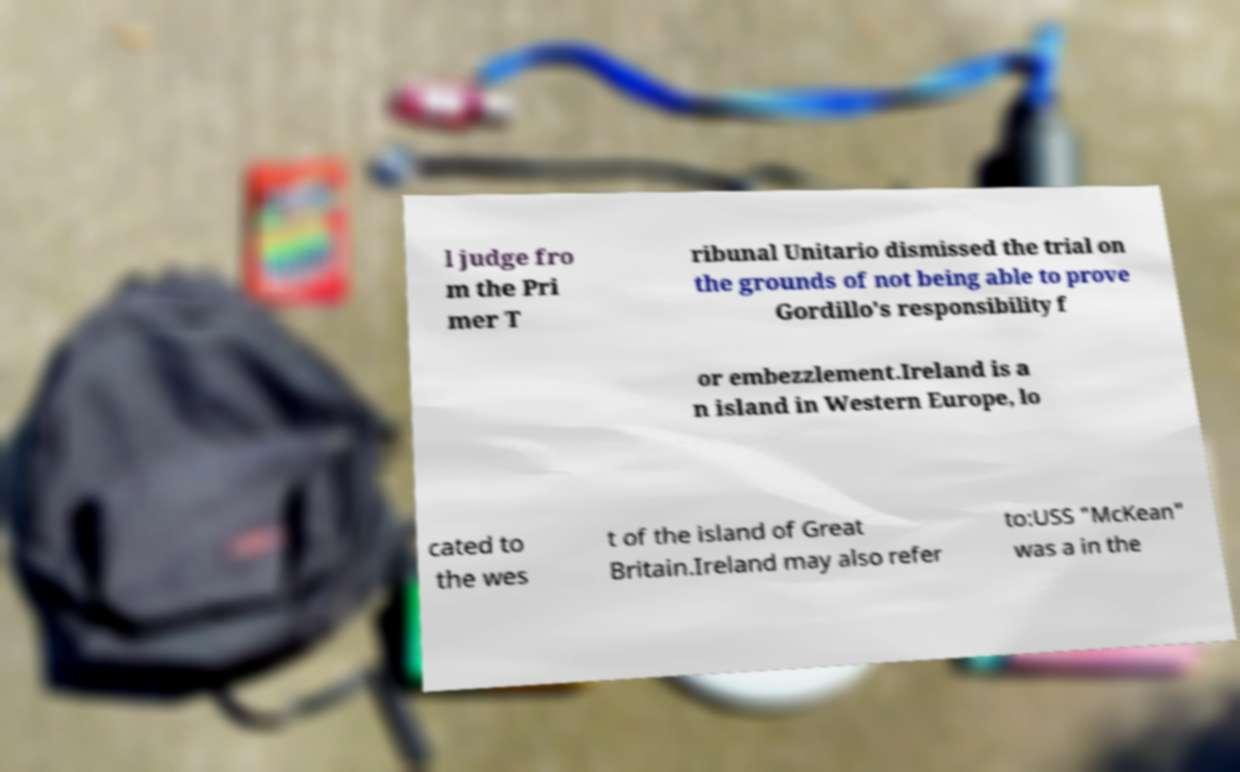There's text embedded in this image that I need extracted. Can you transcribe it verbatim? l judge fro m the Pri mer T ribunal Unitario dismissed the trial on the grounds of not being able to prove Gordillo's responsibility f or embezzlement.Ireland is a n island in Western Europe, lo cated to the wes t of the island of Great Britain.Ireland may also refer to:USS "McKean" was a in the 